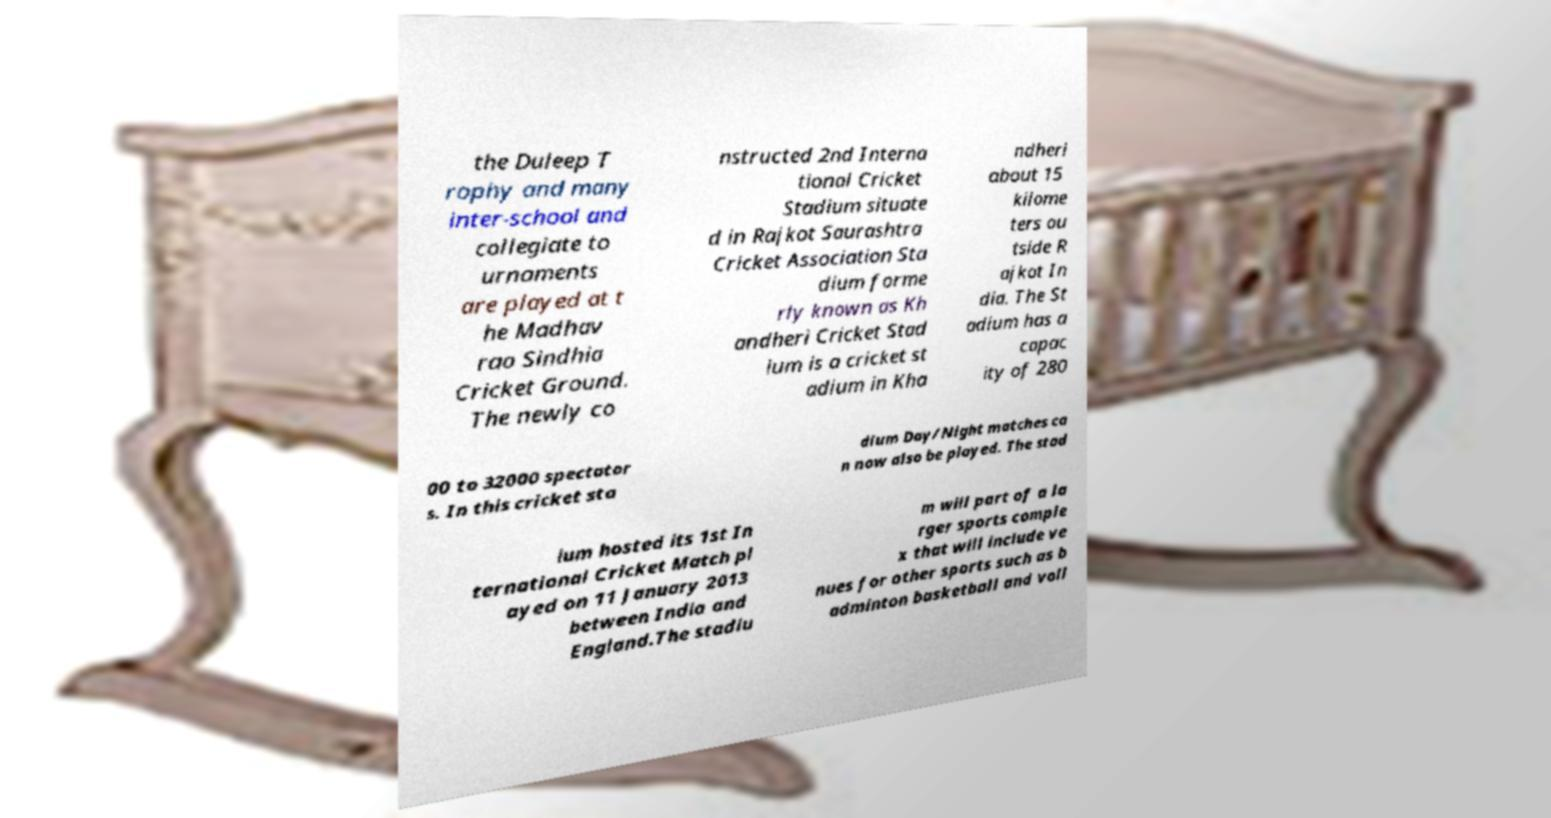What messages or text are displayed in this image? I need them in a readable, typed format. the Duleep T rophy and many inter-school and collegiate to urnaments are played at t he Madhav rao Sindhia Cricket Ground. The newly co nstructed 2nd Interna tional Cricket Stadium situate d in Rajkot Saurashtra Cricket Association Sta dium forme rly known as Kh andheri Cricket Stad ium is a cricket st adium in Kha ndheri about 15 kilome ters ou tside R ajkot In dia. The St adium has a capac ity of 280 00 to 32000 spectator s. In this cricket sta dium Day/Night matches ca n now also be played. The stad ium hosted its 1st In ternational Cricket Match pl ayed on 11 January 2013 between India and England.The stadiu m will part of a la rger sports comple x that will include ve nues for other sports such as b adminton basketball and voll 